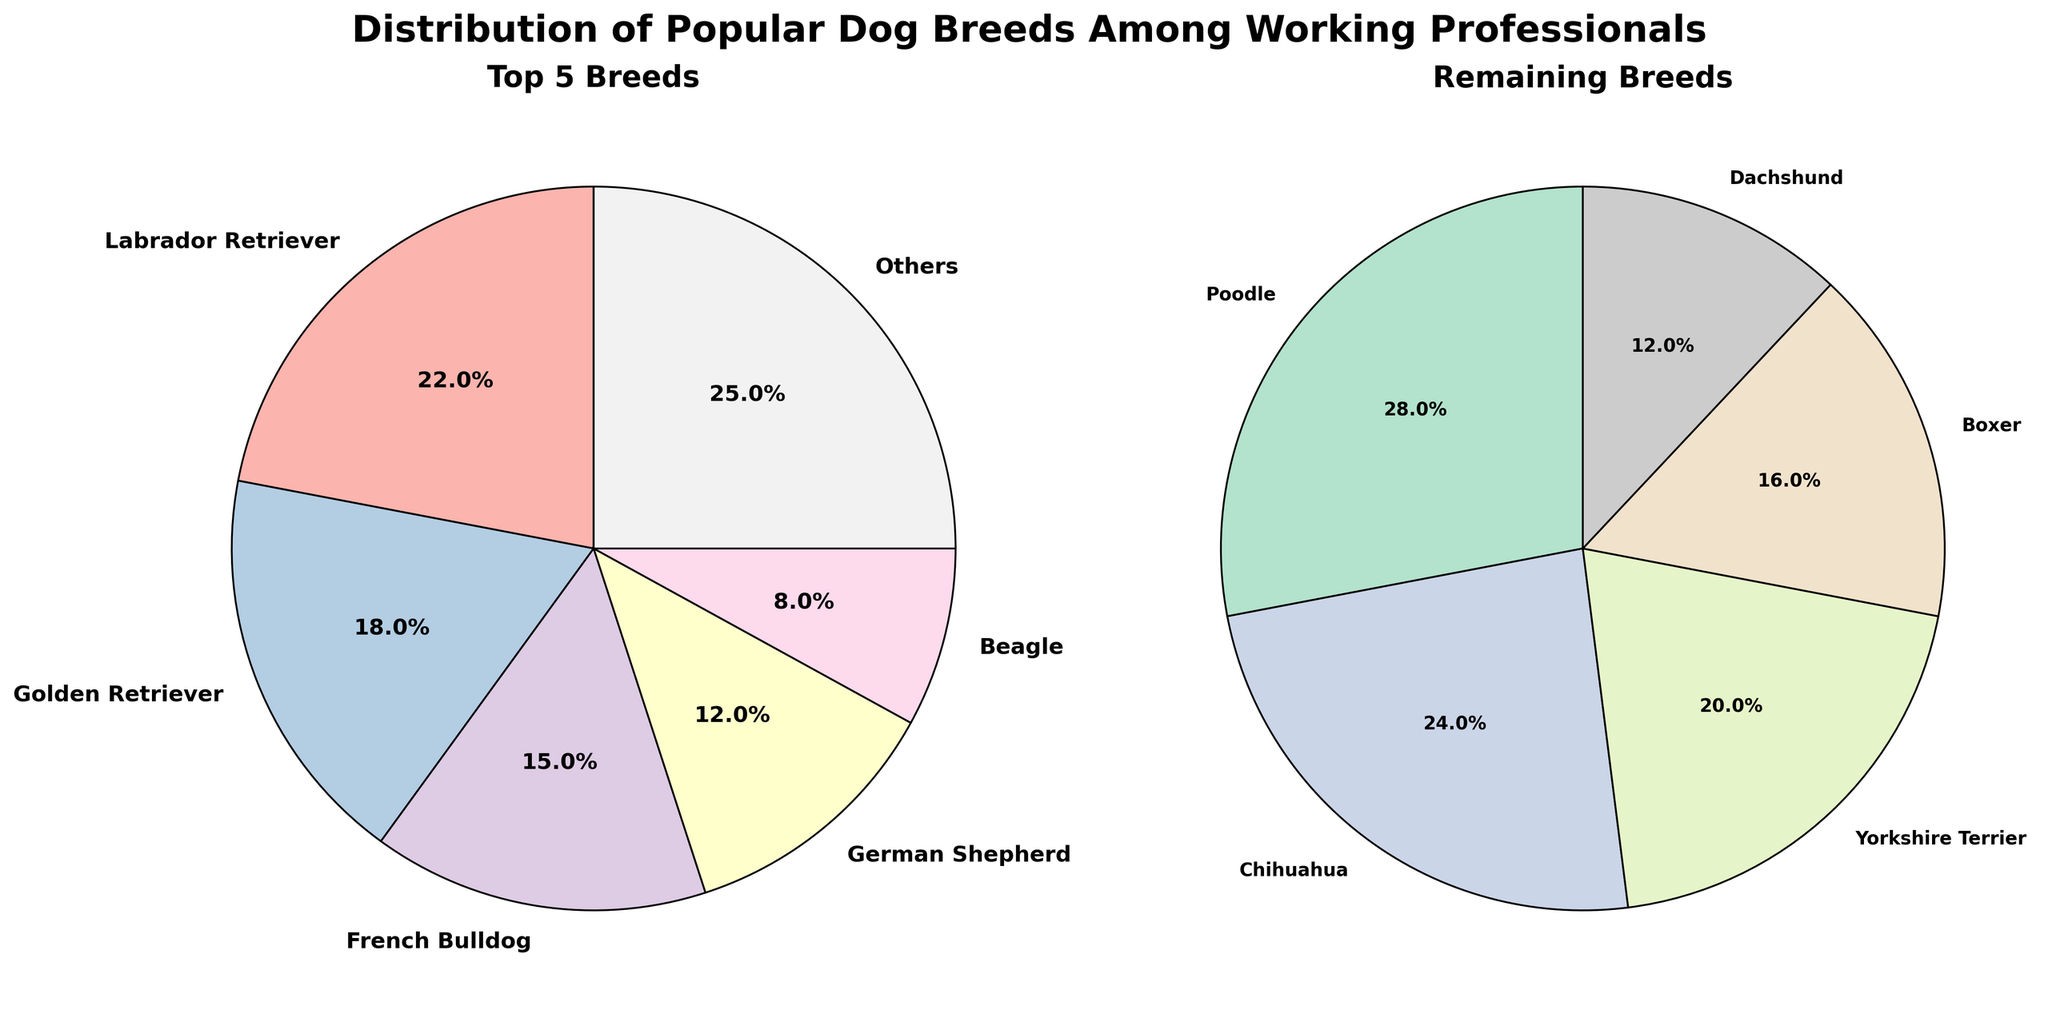What percentage of working professionals own a Labrador Retriever? The pie chart for top 5 breeds indicates the Labrador Retriever segment. According to the chart, it is labeled with "22.0%", which represents the percentage of working professionals who own a Labrador Retriever.
Answer: 22% Which breed follows the Labrador Retriever in popularity among the top 5 breeds? Looking at the pie chart for top 5 breeds, the next largest segment after Labrador Retriever is the Golden Retriever, labeled with 18%.
Answer: Golden Retriever What is the sum of the percentages of the top 5 breeds? To find this, add the percentages of Labrador Retriever (22%), Golden Retriever (18%), French Bulldog (15%), German Shepherd (12%), and Beagle (8%). The sum is 22 + 18 + 15 + 12 + 8 = 75%.
Answer: 75% What is the combined percentage of professionals who own French Bulldogs and Yorkshire Terriers? From the charts, the French Bulldogs segment is 15%, and the Yorkshire Terriers segment is 5%. Adding these percentages gives 15 + 5 = 20%.
Answer: 20% Which breed has the smallest percentage of ownership among the remaining breeds? In the remaining breeds pie chart, the smallest segment is labeled "Dachshund" with 3%.
Answer: Dachshund Are there more working professionals owning Chihuahuas or Boxers, according to the charts? In the remaining breeds pie chart, Chihuahuas are at 6%, while Boxers are at 4%. Therefore, there are more professionals owning Chihuahuas.
Answer: Chihuahuas What color represents Poodles in the remaining breeds chart? Observing the remaining breeds chart, the segment labeled "Poodle" corresponds to a slice of the chart colored near the lighter pastel shades used in the chart.
Answer: Pastel shade (specifically the fifth color segment) What is the total percentage of Beagle owners compared to the combination of Chihuahua and Boxer owners? The percentage for Beagle owners is 8%. Combined percentages for Chihuahua (6%) and Boxer (4%) owners equate to 6 + 4 = 10%. Thus, Chihuahua and Boxer owners together surpass Beagle owners by 2%.
Answer: Beagle: 8%, Chihuahua + Boxer: 10% 